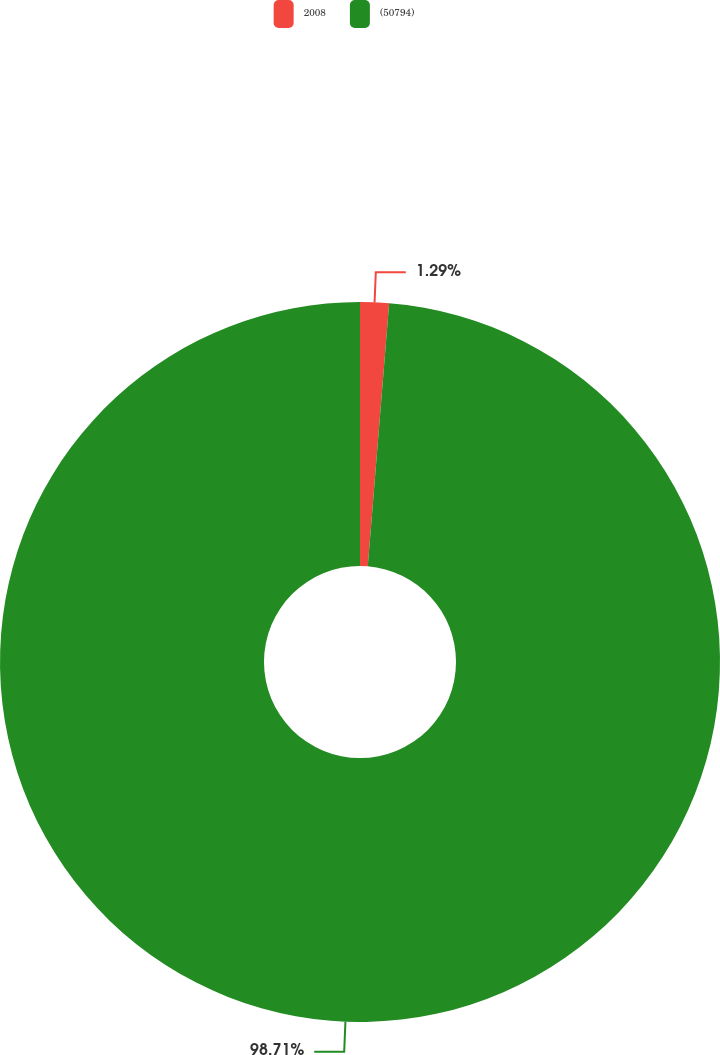Convert chart. <chart><loc_0><loc_0><loc_500><loc_500><pie_chart><fcel>2008<fcel>(50794)<nl><fcel>1.29%<fcel>98.71%<nl></chart> 